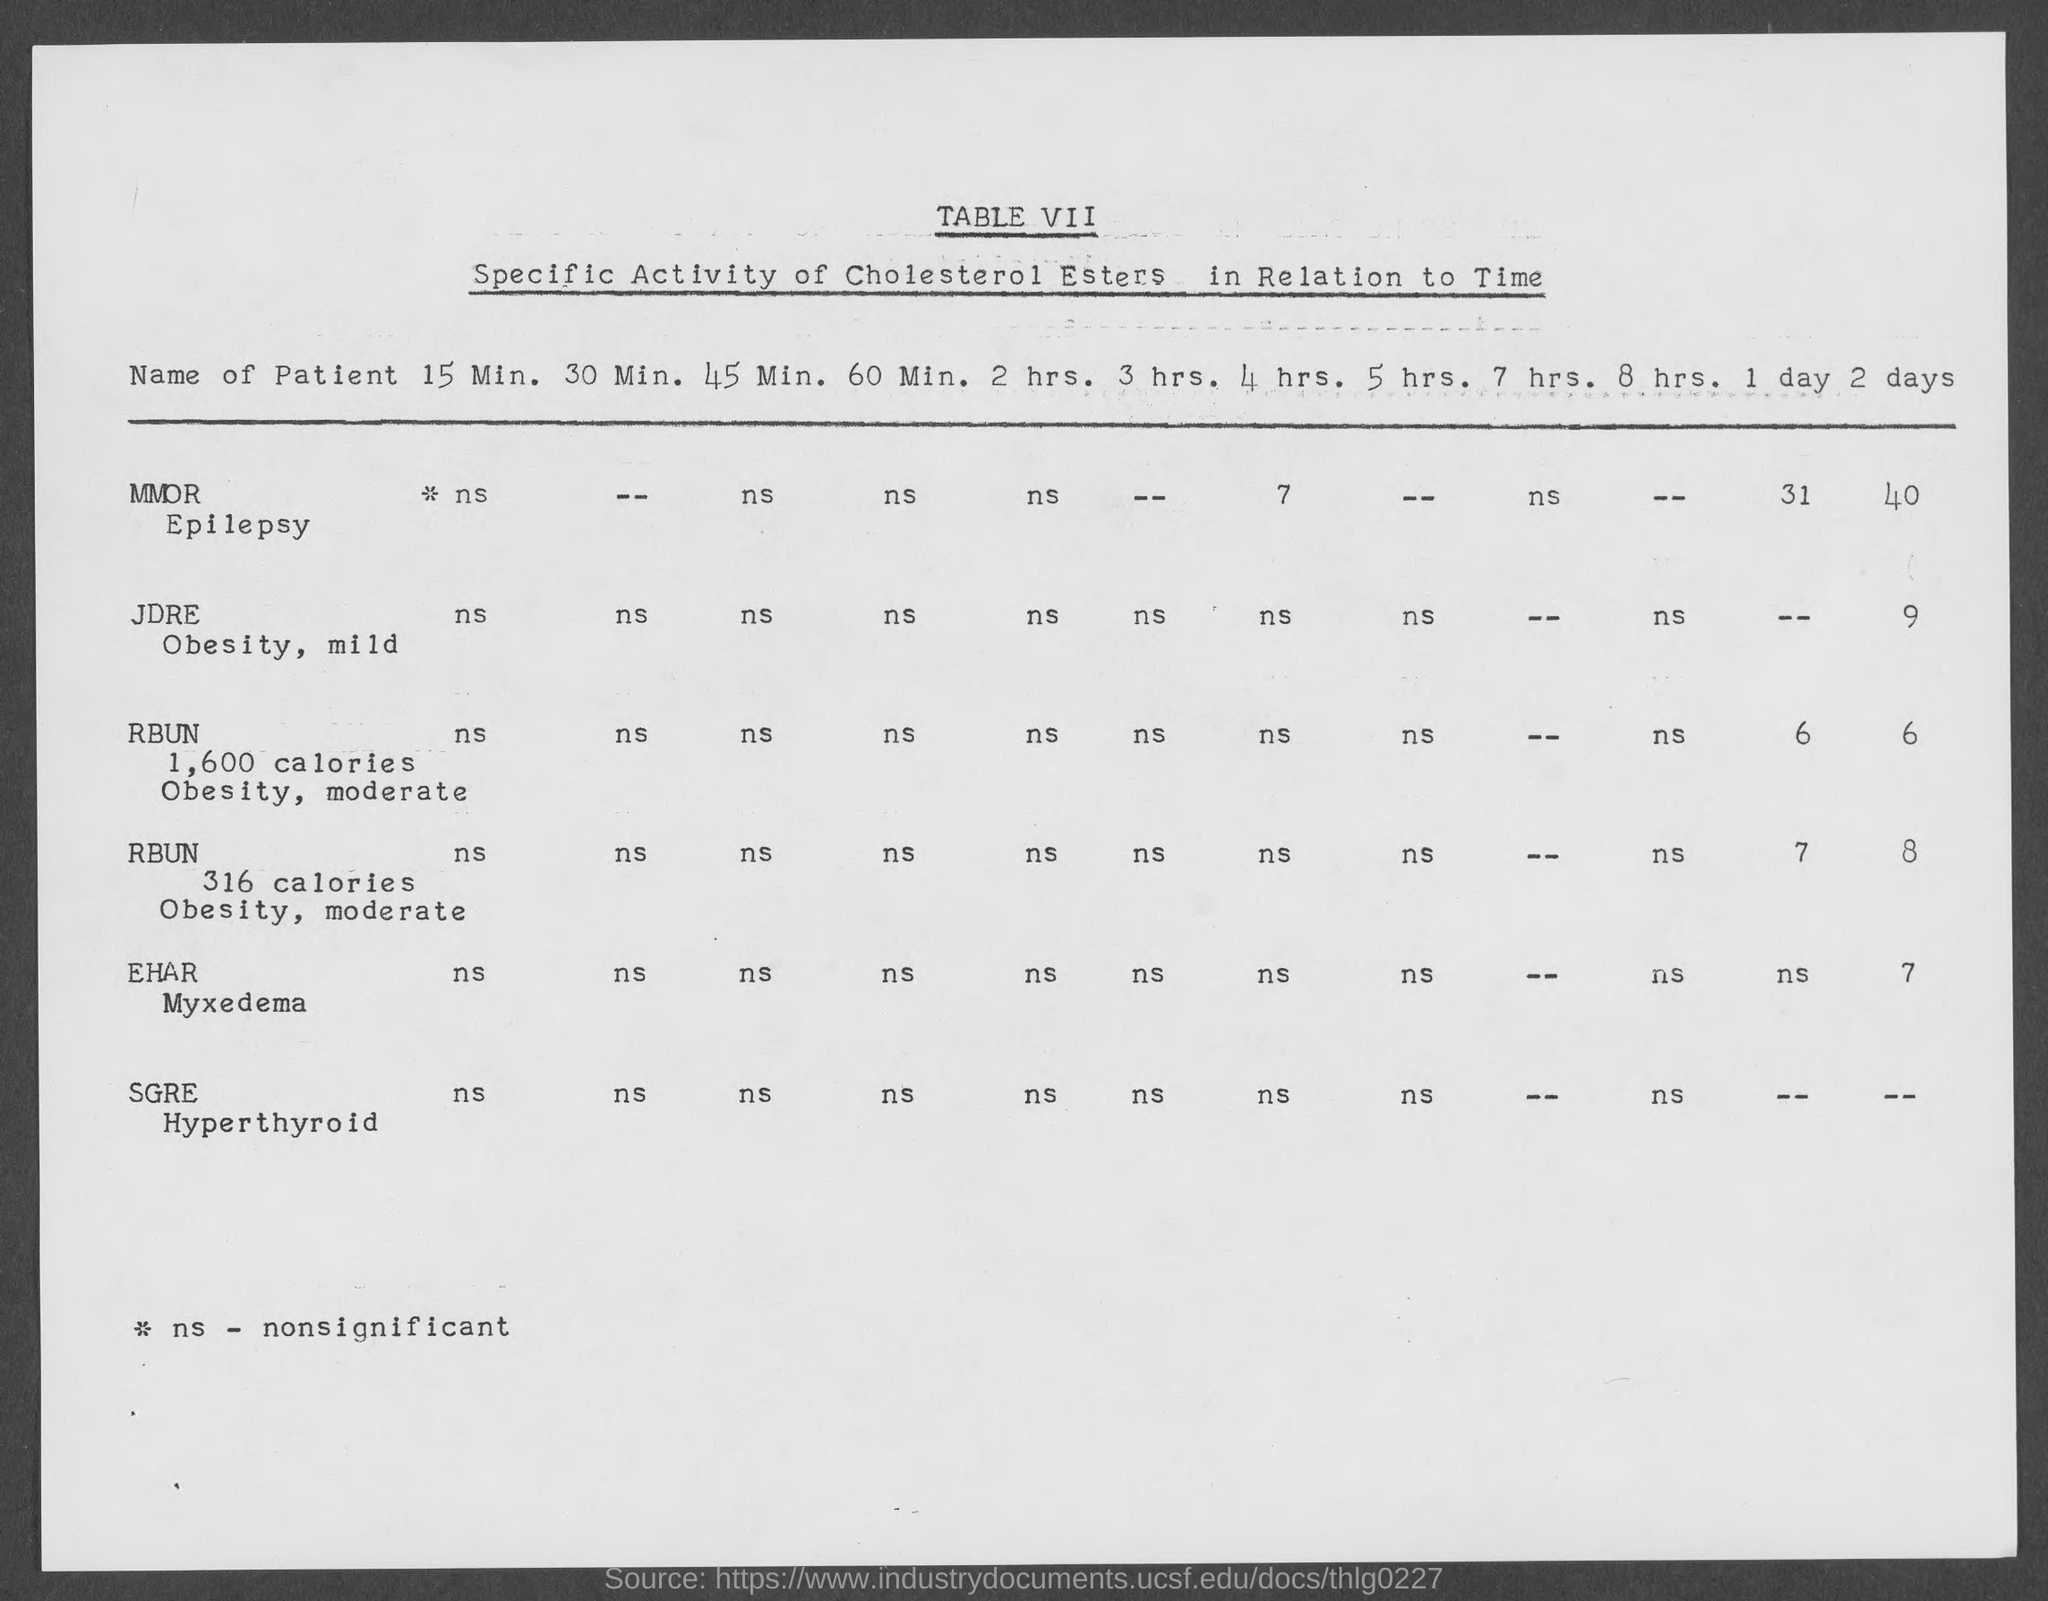What is the title of the table, which is written under the heading "TABLE VII" in the top of the document ??
Give a very brief answer. Specific Activity of Cholesterol Esters in Relation to Time. What is the name of the second patient?
Keep it short and to the point. JDRE. What was the value for "Specific activity of cholesterol ester" for the first patient in 4 hrs?
Provide a succinct answer. 7. What is the fullform of  "ns",shown in the bottom portion of the document?
Provide a succinct answer. Nonsignificant. What is the largest time period ,for which the Specifc activity of cholesterol esters is being found?
Your response must be concise. 2 days. What is the name of the last patient in the document?
Your answer should be compact. SGRE. What is the name of the patient ,which has " Myxedema" disease?
Keep it short and to the point. EHAR. What is the name of the patient ,which has " Hyperthyroid" disease?
Your response must be concise. SGRE. What is the lowest time period ,for which the Specifc activity of cholesterol esters is being valued??
Your response must be concise. 15 Min. Which patient has largest value of cholesterol , when valued in 2 days ?
Ensure brevity in your answer.  MMOR. 